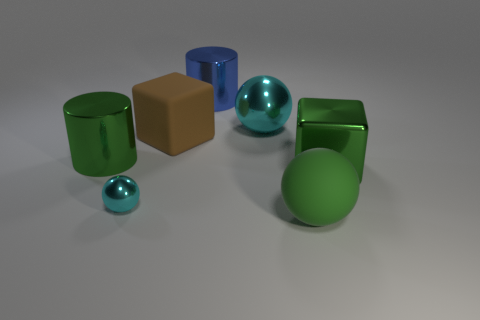Imagine these objects are part of a child's toy set, which of them would fit the role of a ball? The smaller cyan sphere and the larger green sphere would fit the role of balls in a child's toy set due to their round shape and rolling capabilities. 